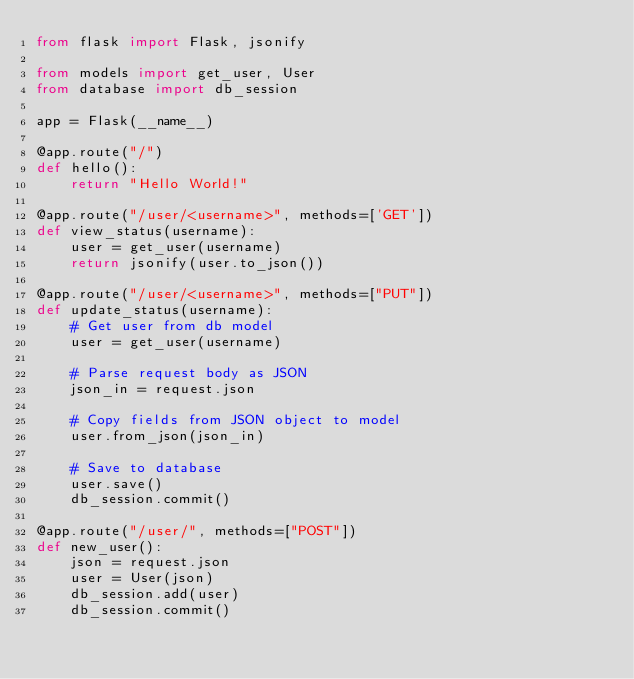Convert code to text. <code><loc_0><loc_0><loc_500><loc_500><_Python_>from flask import Flask, jsonify

from models import get_user, User
from database import db_session

app = Flask(__name__)

@app.route("/")
def hello():
    return "Hello World!"

@app.route("/user/<username>", methods=['GET'])
def view_status(username):
    user = get_user(username)
    return jsonify(user.to_json())

@app.route("/user/<username>", methods=["PUT"])
def update_status(username):
    # Get user from db model
    user = get_user(username)

    # Parse request body as JSON
    json_in = request.json

    # Copy fields from JSON object to model
    user.from_json(json_in)

    # Save to database
    user.save()
    db_session.commit()

@app.route("/user/", methods=["POST"])
def new_user():
    json = request.json
    user = User(json)
    db_session.add(user)
    db_session.commit()

</code> 